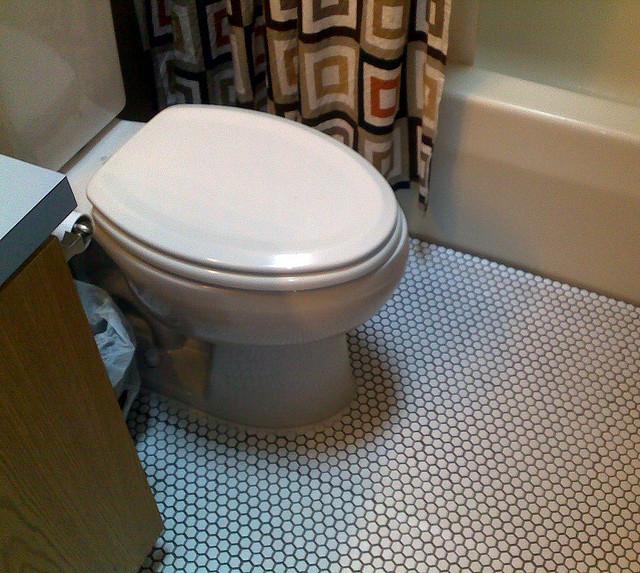What room is this?
Quick response, please. Bathroom. What color is the trash liner?
Answer briefly. White. Is there a sign in the picture?
Quick response, please. No. What is the object in the middle of the picture?
Concise answer only. Toilet. 